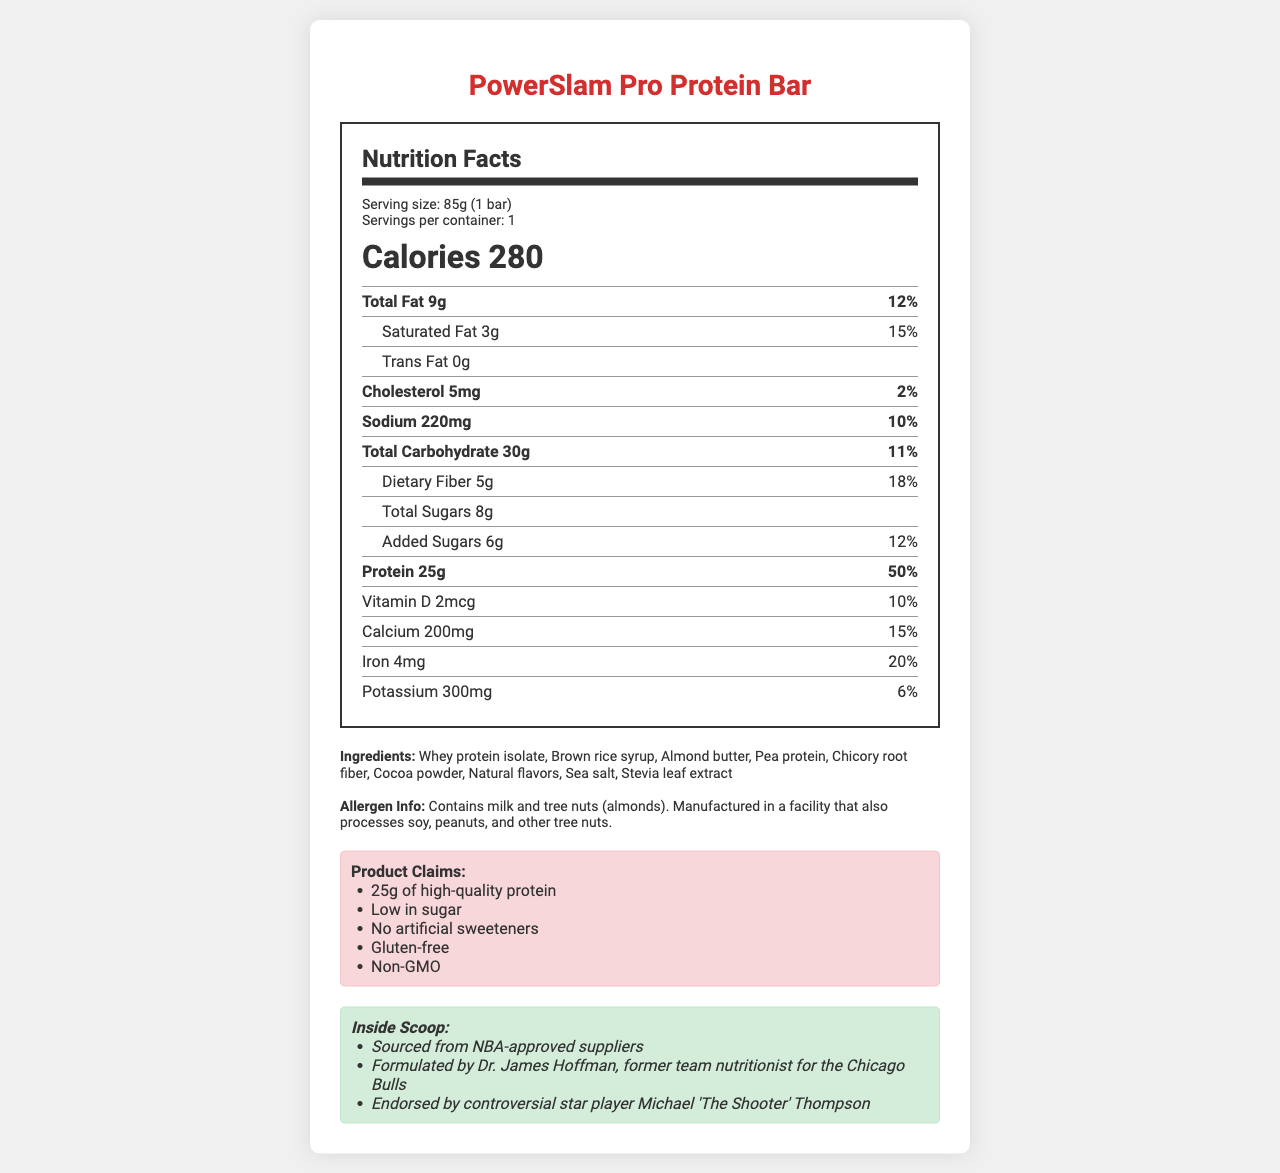what is the serving size of the PowerSlam Pro Protein Bar? The serving size is listed as 85g (1 bar) in the serving info section of the nutrition label.
Answer: 85g (1 bar) how many grams of protein are in one serving? The Protein section specifies that there are 25g of protein in one serving.
Answer: 25g which ingredient is listed first? The ingredient list starts with Whey protein isolate.
Answer: Whey protein isolate what percentage of the daily value is the dietary fiber? The percentage of daily value for dietary fiber is shown as 18%.
Answer: 18% how many calories are in the PowerSlam Pro Protein Bar? The calorie count is prominently displayed as 280.
Answer: 280 what type of allergens does the bar contain? The allergen info section states that the bar contains milk and tree nuts (almonds).
Answer: Milk and tree nuts (almonds) which of the following is a marketing claim for this bar? A. Low Sodium B. Low in sugar C. High Cholesterol D. High in Fiber One of the marketing claims listed is "Low in sugar".
Answer: B. Low in sugar what vitamin is included in the nutrition label? A. Vitamin C B. Vitamin D C. Vitamin B12 D. Vitamin A The nutrition label specifies 2mcg (10% DV) of Vitamin D.
Answer: B. Vitamin D is the PowerSlam Pro Protein Bar gluten-free? One of the marketing claims is "Gluten-free".
Answer: Yes describe the main elements of the nutrition label for the PowerSlam Pro Protein Bar. The document is a visual nutrition facts label for the PowerSlam Pro Protein Bar, including detailed nutritional information, ingredients, allergen info, marketing claims, and scandal hints.
Answer: The label provides comprehensive nutritional information for each serving size, which is 85g (1 bar). It includes calories, macronutrients like total fat, saturated fat, trans fat, cholesterol, sodium, total carbohydrates, dietary fiber, total sugars, added sugars, protein, and micronutrients such as vitamin D, calcium, iron, and potassium. It lists the ingredients and includes allergen information. Furthermore, the product's marketing claims and some scandal-related hints are provided. what is the main source of protein in the PowerSlam Pro Protein Bar? The document lists multiple protein sources like Whey protein isolate and Pea protein, but it does not specify which is the main source.
Answer: Cannot be determined what is the relationship between Dr. James Hoffman and the NBA? The scandal hints section mentions Dr. James Hoffman as a former team nutritionist for the Chicago Bulls, indicating his relationship with the NBA.
Answer: Formulated by Dr. James Hoffman, former team nutritionist for the Chicago Bulls 